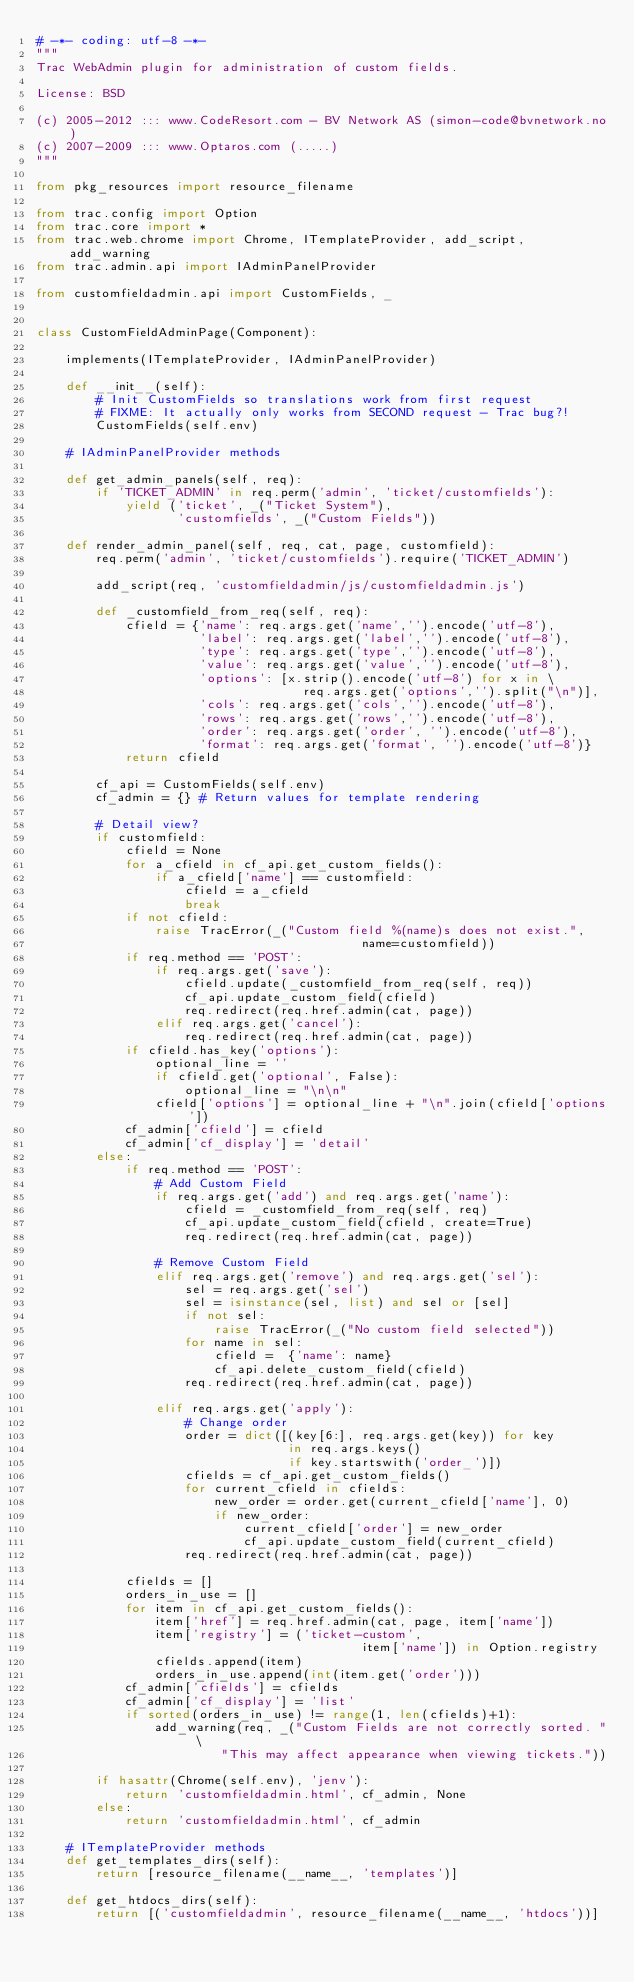Convert code to text. <code><loc_0><loc_0><loc_500><loc_500><_Python_># -*- coding: utf-8 -*-
"""
Trac WebAdmin plugin for administration of custom fields.

License: BSD

(c) 2005-2012 ::: www.CodeResort.com - BV Network AS (simon-code@bvnetwork.no)
(c) 2007-2009 ::: www.Optaros.com (.....)
"""

from pkg_resources import resource_filename

from trac.config import Option
from trac.core import *
from trac.web.chrome import Chrome, ITemplateProvider, add_script, add_warning
from trac.admin.api import IAdminPanelProvider

from customfieldadmin.api import CustomFields, _


class CustomFieldAdminPage(Component):

    implements(ITemplateProvider, IAdminPanelProvider)

    def __init__(self):
        # Init CustomFields so translations work from first request
        # FIXME: It actually only works from SECOND request - Trac bug?!
        CustomFields(self.env)

    # IAdminPanelProvider methods

    def get_admin_panels(self, req):
        if 'TICKET_ADMIN' in req.perm('admin', 'ticket/customfields'):
            yield ('ticket', _("Ticket System"),
                   'customfields', _("Custom Fields"))

    def render_admin_panel(self, req, cat, page, customfield):
        req.perm('admin', 'ticket/customfields').require('TICKET_ADMIN')

        add_script(req, 'customfieldadmin/js/customfieldadmin.js')

        def _customfield_from_req(self, req):
            cfield = {'name': req.args.get('name','').encode('utf-8'),
                      'label': req.args.get('label','').encode('utf-8'),
                      'type': req.args.get('type','').encode('utf-8'),
                      'value': req.args.get('value','').encode('utf-8'),
                      'options': [x.strip().encode('utf-8') for x in \
                                    req.args.get('options','').split("\n")],
                      'cols': req.args.get('cols','').encode('utf-8'),
                      'rows': req.args.get('rows','').encode('utf-8'),
                      'order': req.args.get('order', '').encode('utf-8'),
                      'format': req.args.get('format', '').encode('utf-8')}
            return cfield

        cf_api = CustomFields(self.env)
        cf_admin = {} # Return values for template rendering

        # Detail view?
        if customfield:
            cfield = None
            for a_cfield in cf_api.get_custom_fields():
                if a_cfield['name'] == customfield:
                    cfield = a_cfield
                    break
            if not cfield:
                raise TracError(_("Custom field %(name)s does not exist.",
                                            name=customfield))
            if req.method == 'POST':
                if req.args.get('save'):
                    cfield.update(_customfield_from_req(self, req))
                    cf_api.update_custom_field(cfield)
                    req.redirect(req.href.admin(cat, page))
                elif req.args.get('cancel'):
                    req.redirect(req.href.admin(cat, page))
            if cfield.has_key('options'):
                optional_line = ''
                if cfield.get('optional', False):
                    optional_line = "\n\n"
                cfield['options'] = optional_line + "\n".join(cfield['options'])
            cf_admin['cfield'] = cfield
            cf_admin['cf_display'] = 'detail'
        else:
            if req.method == 'POST':
                # Add Custom Field
                if req.args.get('add') and req.args.get('name'):
                    cfield = _customfield_from_req(self, req)
                    cf_api.update_custom_field(cfield, create=True)
                    req.redirect(req.href.admin(cat, page))

                # Remove Custom Field
                elif req.args.get('remove') and req.args.get('sel'):
                    sel = req.args.get('sel')
                    sel = isinstance(sel, list) and sel or [sel]
                    if not sel:
                        raise TracError(_("No custom field selected"))
                    for name in sel:
                        cfield =  {'name': name}
                        cf_api.delete_custom_field(cfield)
                    req.redirect(req.href.admin(cat, page))

                elif req.args.get('apply'):
                    # Change order
                    order = dict([(key[6:], req.args.get(key)) for key
                                  in req.args.keys()
                                  if key.startswith('order_')])
                    cfields = cf_api.get_custom_fields()
                    for current_cfield in cfields:
                        new_order = order.get(current_cfield['name'], 0)
                        if new_order:
                            current_cfield['order'] = new_order
                            cf_api.update_custom_field(current_cfield)
                    req.redirect(req.href.admin(cat, page))

            cfields = []
            orders_in_use = []
            for item in cf_api.get_custom_fields():
                item['href'] = req.href.admin(cat, page, item['name'])
                item['registry'] = ('ticket-custom',
                                            item['name']) in Option.registry
                cfields.append(item)
                orders_in_use.append(int(item.get('order')))
            cf_admin['cfields'] = cfields
            cf_admin['cf_display'] = 'list'
            if sorted(orders_in_use) != range(1, len(cfields)+1):
                add_warning(req, _("Custom Fields are not correctly sorted. " \
                         "This may affect appearance when viewing tickets."))

        if hasattr(Chrome(self.env), 'jenv'):
            return 'customfieldadmin.html', cf_admin, None
        else:
            return 'customfieldadmin.html', cf_admin

    # ITemplateProvider methods
    def get_templates_dirs(self):
        return [resource_filename(__name__, 'templates')]

    def get_htdocs_dirs(self):
        return [('customfieldadmin', resource_filename(__name__, 'htdocs'))]
</code> 